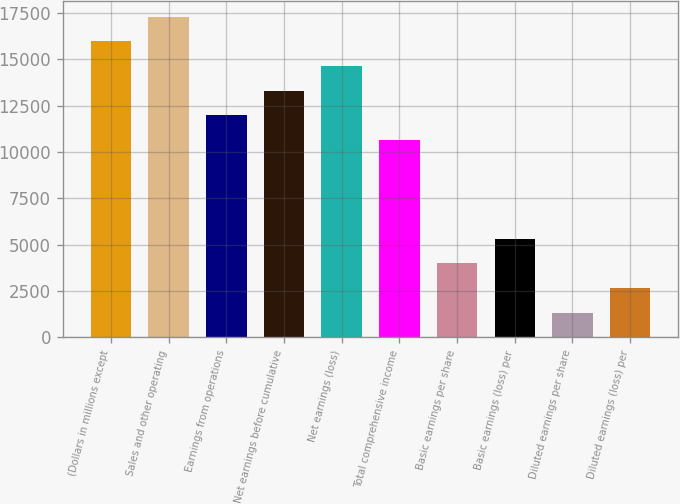Convert chart to OTSL. <chart><loc_0><loc_0><loc_500><loc_500><bar_chart><fcel>(Dollars in millions except<fcel>Sales and other operating<fcel>Earnings from operations<fcel>Net earnings before cumulative<fcel>Net earnings (loss)<fcel>Total comprehensive income<fcel>Basic earnings per share<fcel>Basic earnings (loss) per<fcel>Diluted earnings per share<fcel>Diluted earnings (loss) per<nl><fcel>15951.5<fcel>17280.8<fcel>11963.7<fcel>13293<fcel>14622.2<fcel>10634.4<fcel>3988.01<fcel>5317.29<fcel>1329.45<fcel>2658.73<nl></chart> 